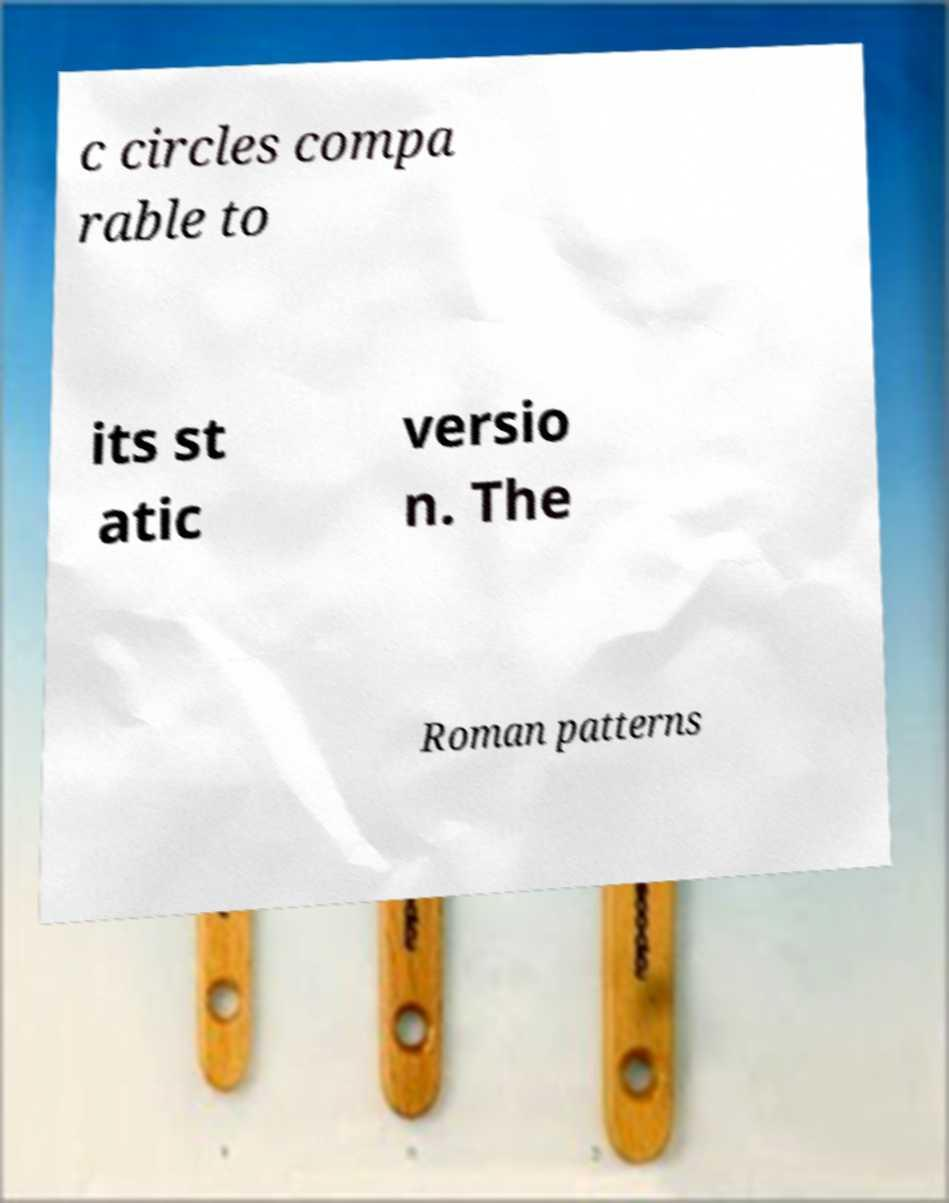For documentation purposes, I need the text within this image transcribed. Could you provide that? c circles compa rable to its st atic versio n. The Roman patterns 